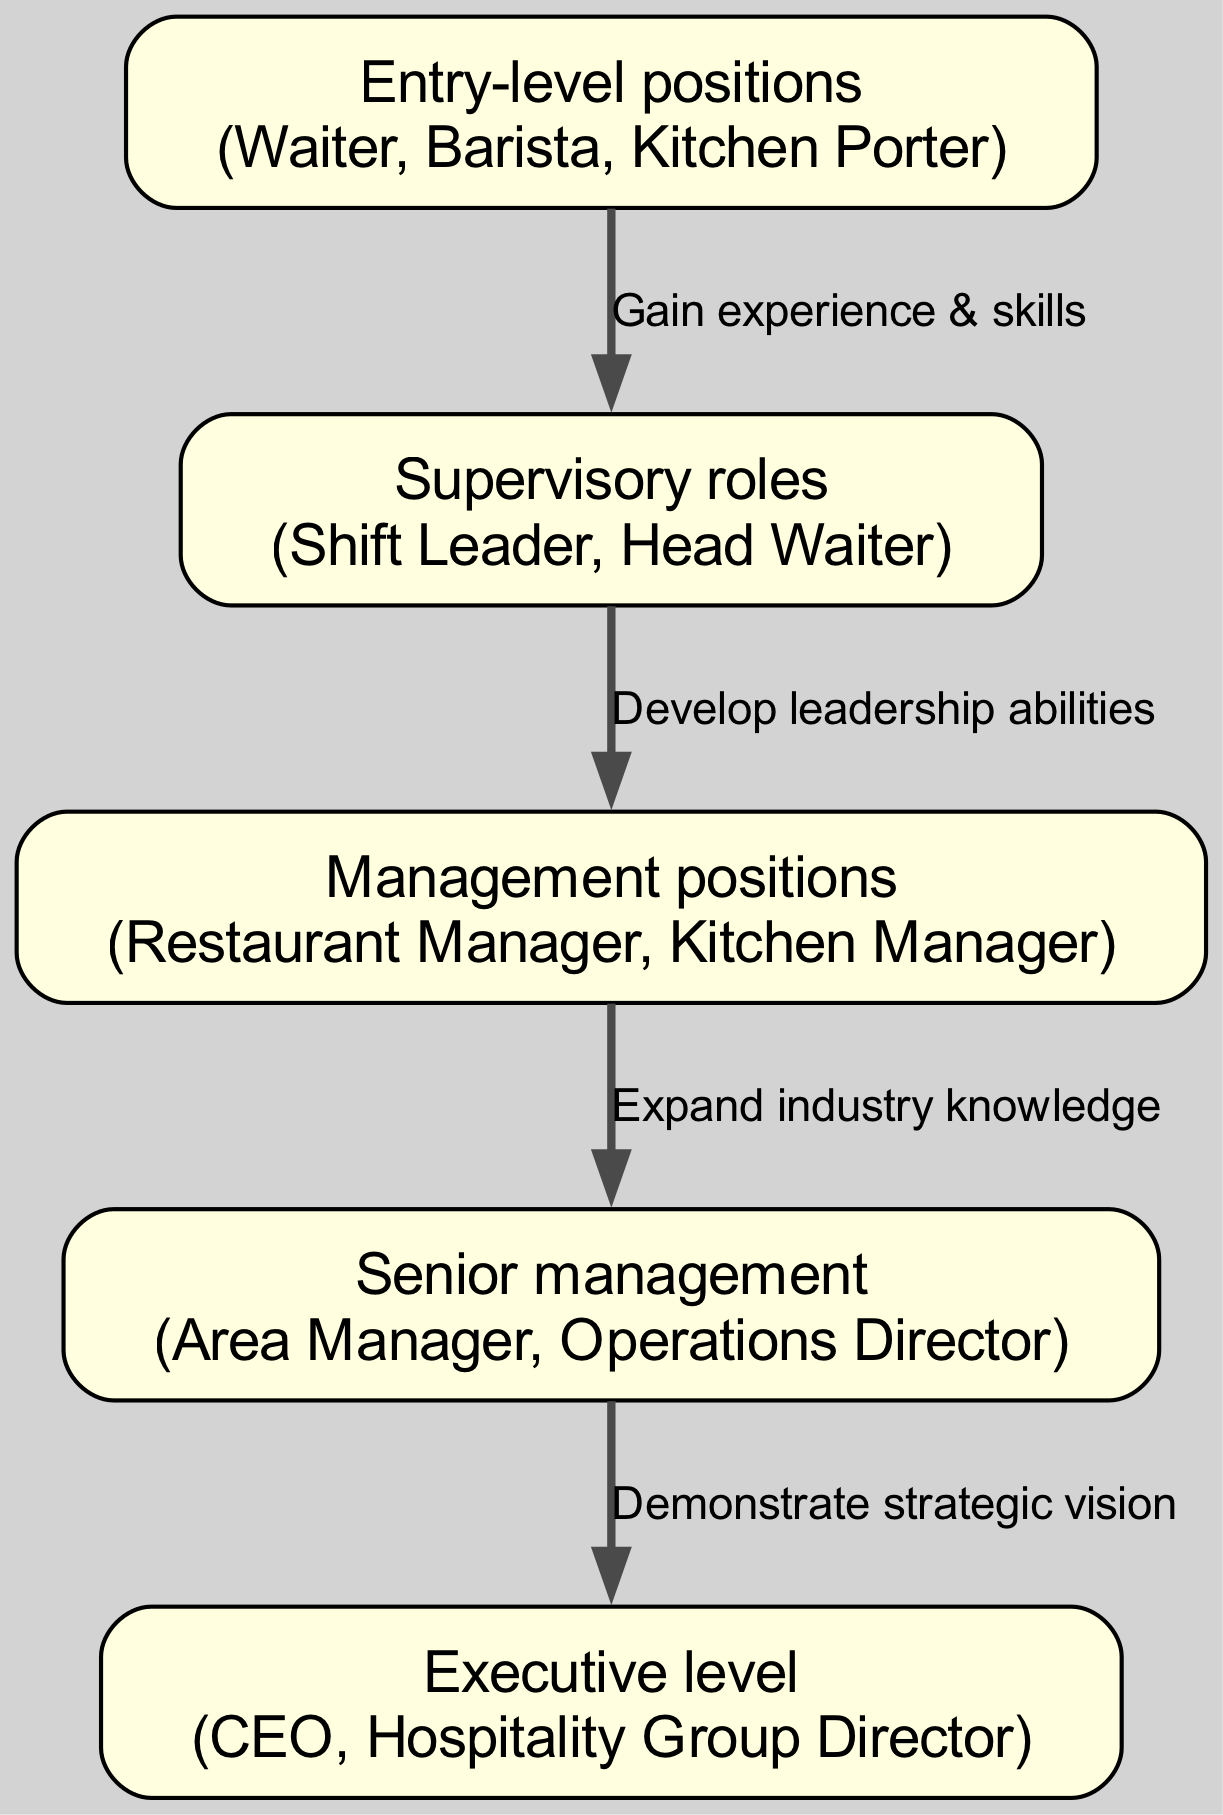What are some entry-level positions in the UK food and hospitality industry? The diagram specifies that entry-level positions include Waiter, Barista, and Kitchen Porter. These roles are listed directly under the "Entry-level positions" node.
Answer: Waiter, Barista, Kitchen Porter How many nodes are there in the career progression diagram? The diagram contains five distinct nodes: Entry-level positions, Supervisory roles, Management positions, Senior management, and Executive level. Therefore, the total count is five.
Answer: 5 What is required to move from Entry-level positions to Supervisory roles? According to the diagram, the relationship is defined as "Gain experience & skills." This indicates that acquiring relevant experience and skills is necessary for promotion to supervisory roles.
Answer: Gain experience & skills Which position follows directly after Management positions? The diagram shows that Senior management comes directly after Management positions. This can be determined by looking at the edge connection from the Management positions node to the Senior management node.
Answer: Senior management What is the strategic vision needed to progress from Senior management to Executive level? The diagram specifies that to progress from Senior management to Executive level, one must "Demonstrate strategic vision." This phrase succinctly captures what is required for advancement at this level.
Answer: Demonstrate strategic vision What role is directly before Operations Director in the career path? In the diagram, Operations Director is under the Senior management level, and directly before it is the Management positions level, which includes roles like Restaurant Manager and Kitchen Manager. Therefore, Management positions is the direct preceding role.
Answer: Management positions Which relationship is shown between Supervisory roles and Management positions? The relationship is indicated as "Develop leadership abilities." This means developing leadership is essential for moving from Supervisory roles to Management positions.
Answer: Develop leadership abilities How does the career path progress from Entry-level positions to Executive level? The progression begins with gaining experience and skills to move to Supervisory roles, then developing leadership abilities to reach Management positions, expanding industry knowledge for Senior management, and finally demonstrating strategic vision for the Executive level. The connections need to be followed sequentially through all the nodes to understand this flow.
Answer: Entry-level positions -> Supervisory roles -> Management positions -> Senior management -> Executive level 